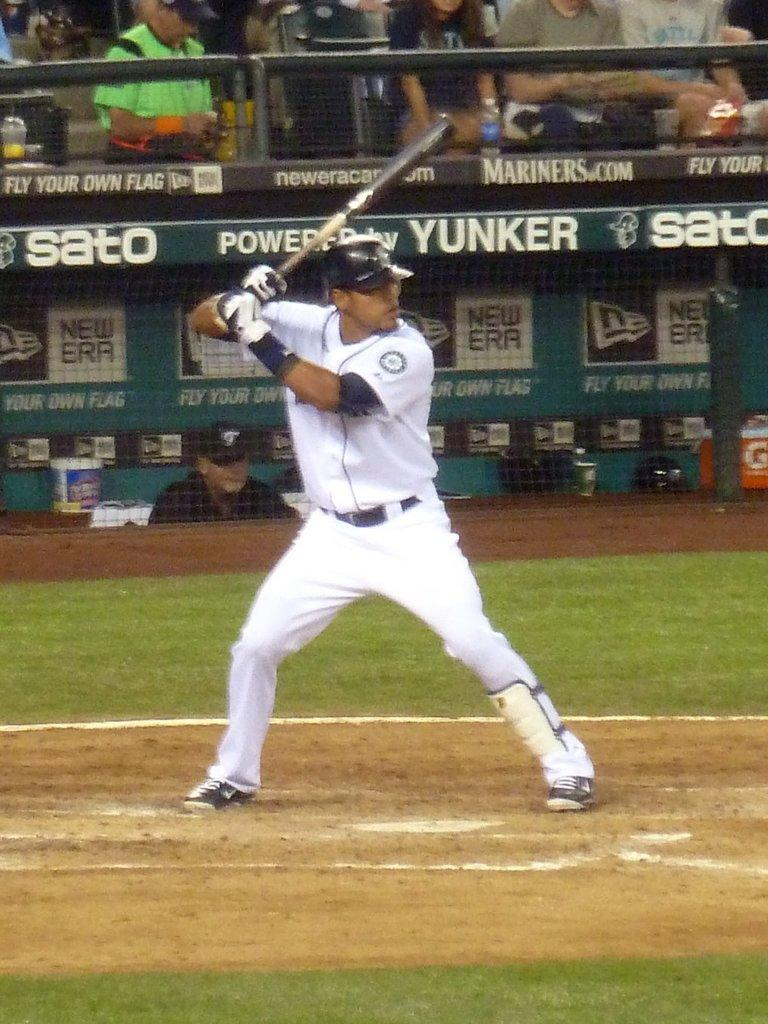<image>
Describe the image concisely. A signboard advertising SATO at a baseball stadium. 